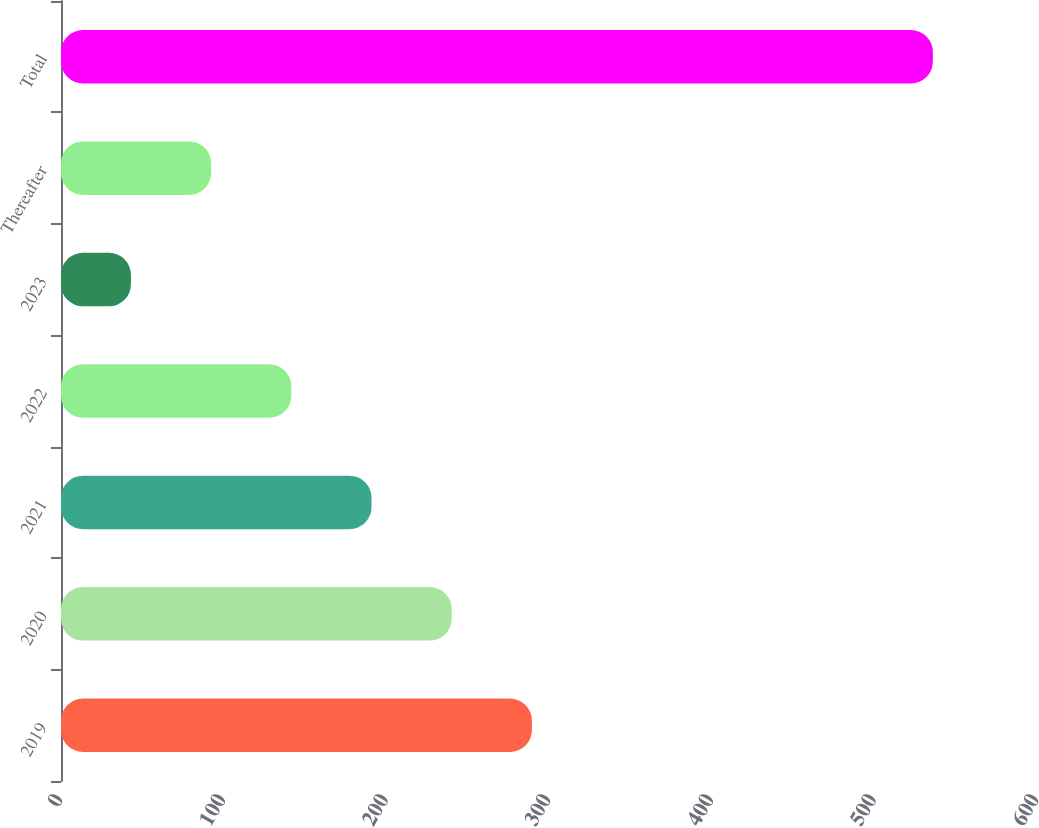Convert chart to OTSL. <chart><loc_0><loc_0><loc_500><loc_500><bar_chart><fcel>2019<fcel>2020<fcel>2021<fcel>2022<fcel>2023<fcel>Thereafter<fcel>Total<nl><fcel>289.5<fcel>240.2<fcel>190.9<fcel>141.6<fcel>43<fcel>92.3<fcel>536<nl></chart> 